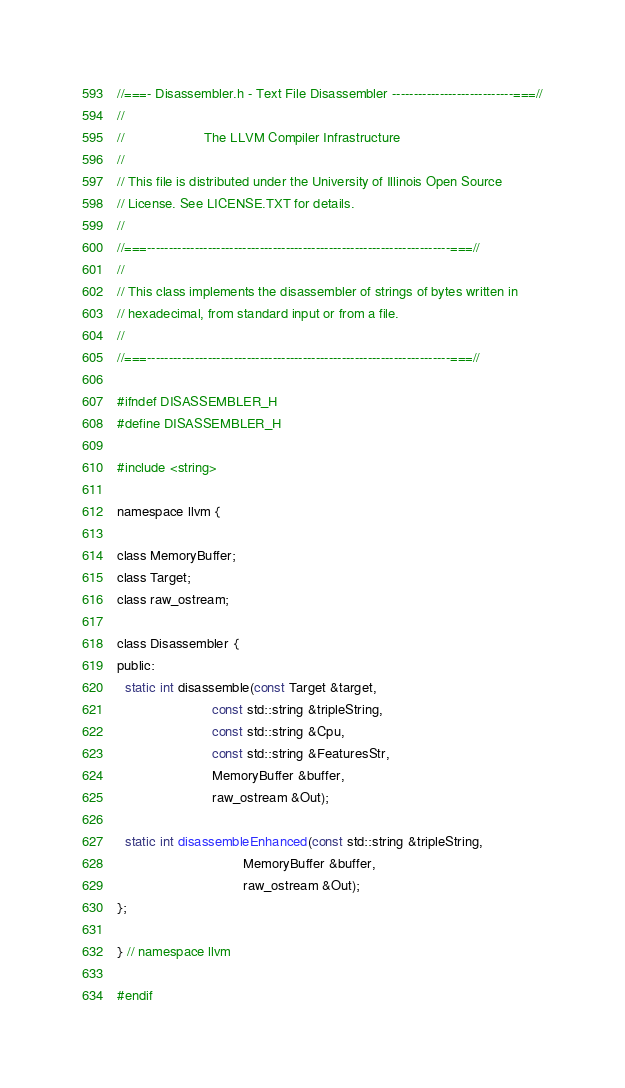<code> <loc_0><loc_0><loc_500><loc_500><_C_>//===- Disassembler.h - Text File Disassembler ----------------------------===//
//
//                     The LLVM Compiler Infrastructure
//
// This file is distributed under the University of Illinois Open Source
// License. See LICENSE.TXT for details.
//
//===----------------------------------------------------------------------===//
//
// This class implements the disassembler of strings of bytes written in
// hexadecimal, from standard input or from a file.
//
//===----------------------------------------------------------------------===//

#ifndef DISASSEMBLER_H
#define DISASSEMBLER_H

#include <string>

namespace llvm {

class MemoryBuffer;
class Target;
class raw_ostream;

class Disassembler {
public:
  static int disassemble(const Target &target,
                         const std::string &tripleString,
                         const std::string &Cpu,
                         const std::string &FeaturesStr,
                         MemoryBuffer &buffer,
                         raw_ostream &Out);

  static int disassembleEnhanced(const std::string &tripleString,
                                 MemoryBuffer &buffer,
                                 raw_ostream &Out);
};

} // namespace llvm

#endif
</code> 